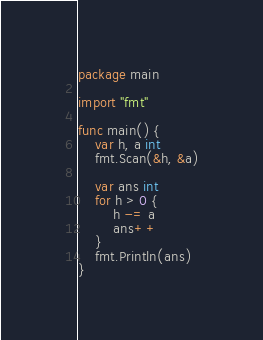<code> <loc_0><loc_0><loc_500><loc_500><_Go_>package main

import "fmt"

func main() {
	var h, a int
	fmt.Scan(&h, &a)

	var ans int
	for h > 0 {
		h -= a
		ans++
	}
	fmt.Println(ans)
}
</code> 